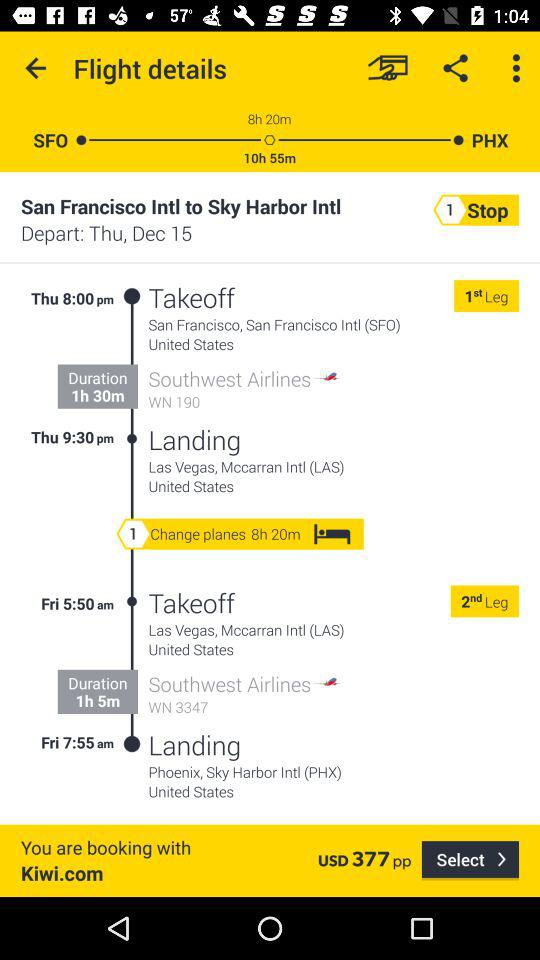What is the duration of the 1st leg? The duration is 1 hour 30 minutes. 